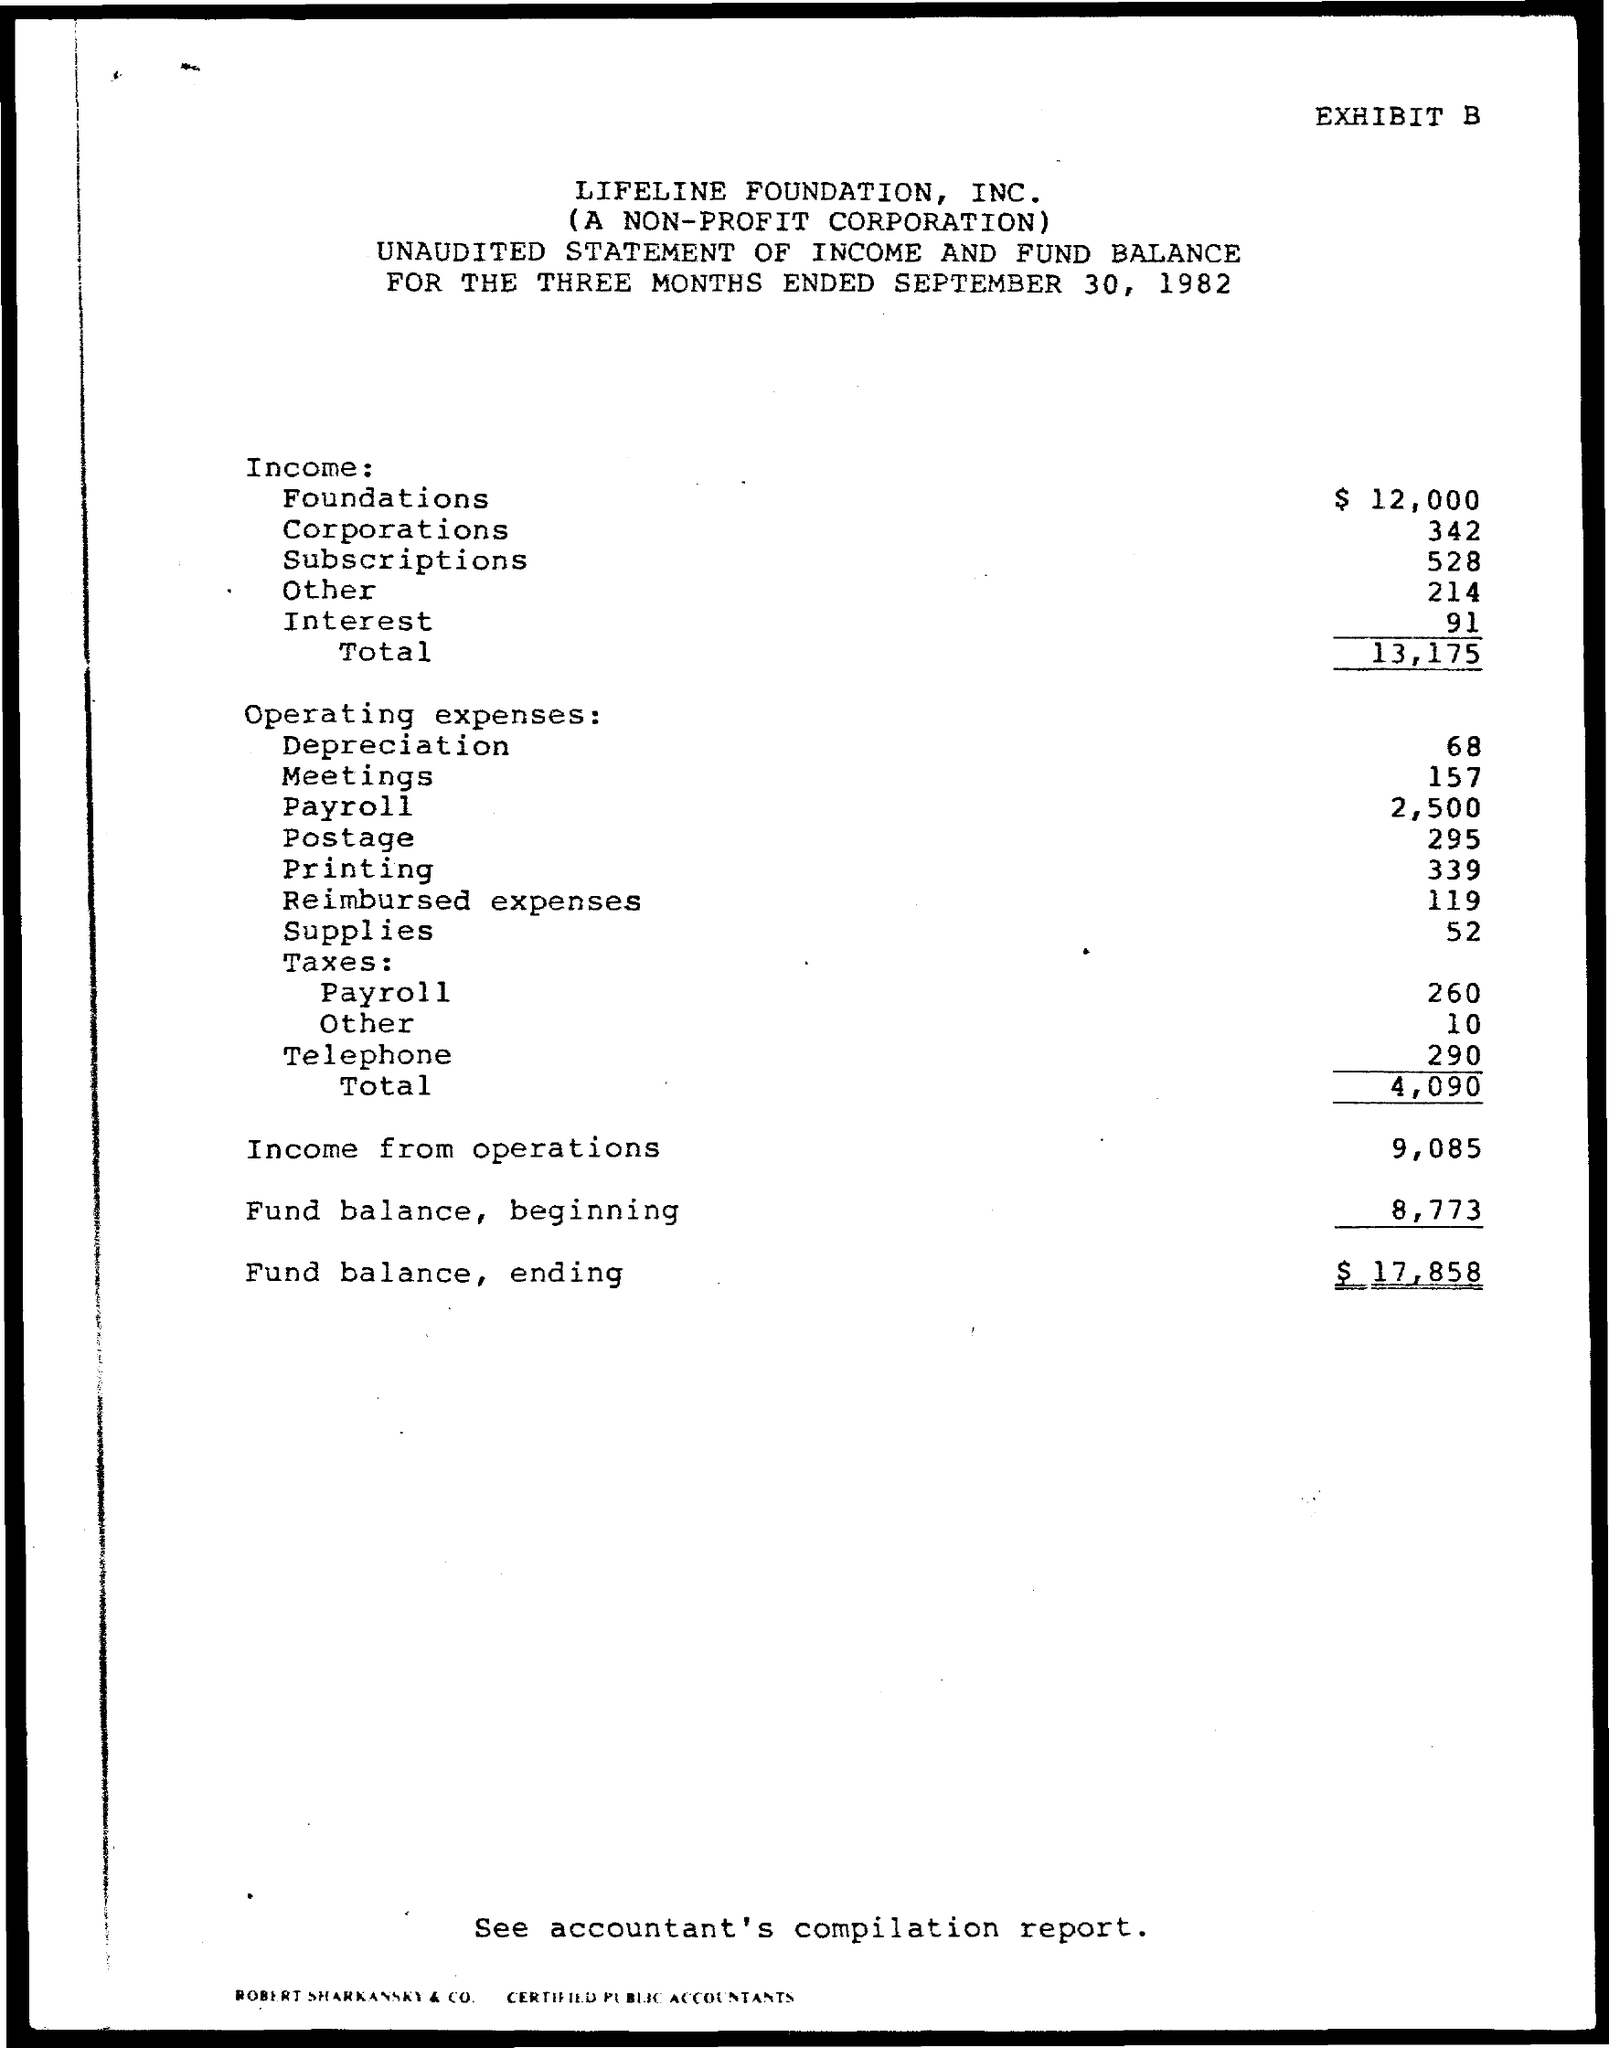Mention a couple of crucial points in this snapshot. The total income for the three months ended September 30, 1982, was 13,175. The fund balance in the ending for the three months ended September 30, 1982 was $17,858. The fund balance in the beginning for the three months ended September 30, 1982 was $8,773. The total operating expenses for the three months ended September 30, 1982, were 4,090... The income from operations for the three months ended September 30, 1982 was $9,085. 